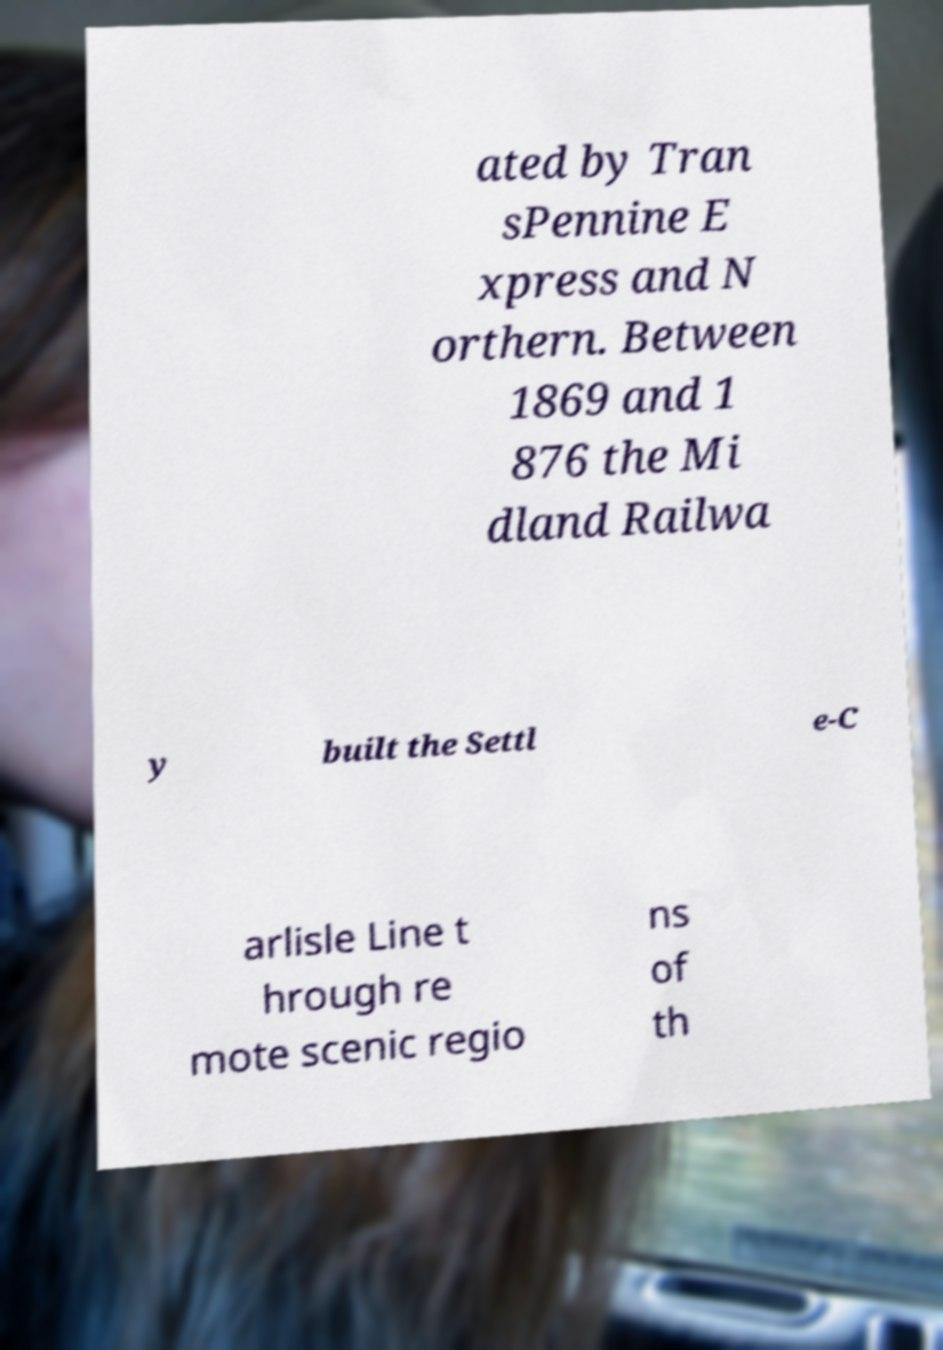I need the written content from this picture converted into text. Can you do that? ated by Tran sPennine E xpress and N orthern. Between 1869 and 1 876 the Mi dland Railwa y built the Settl e-C arlisle Line t hrough re mote scenic regio ns of th 